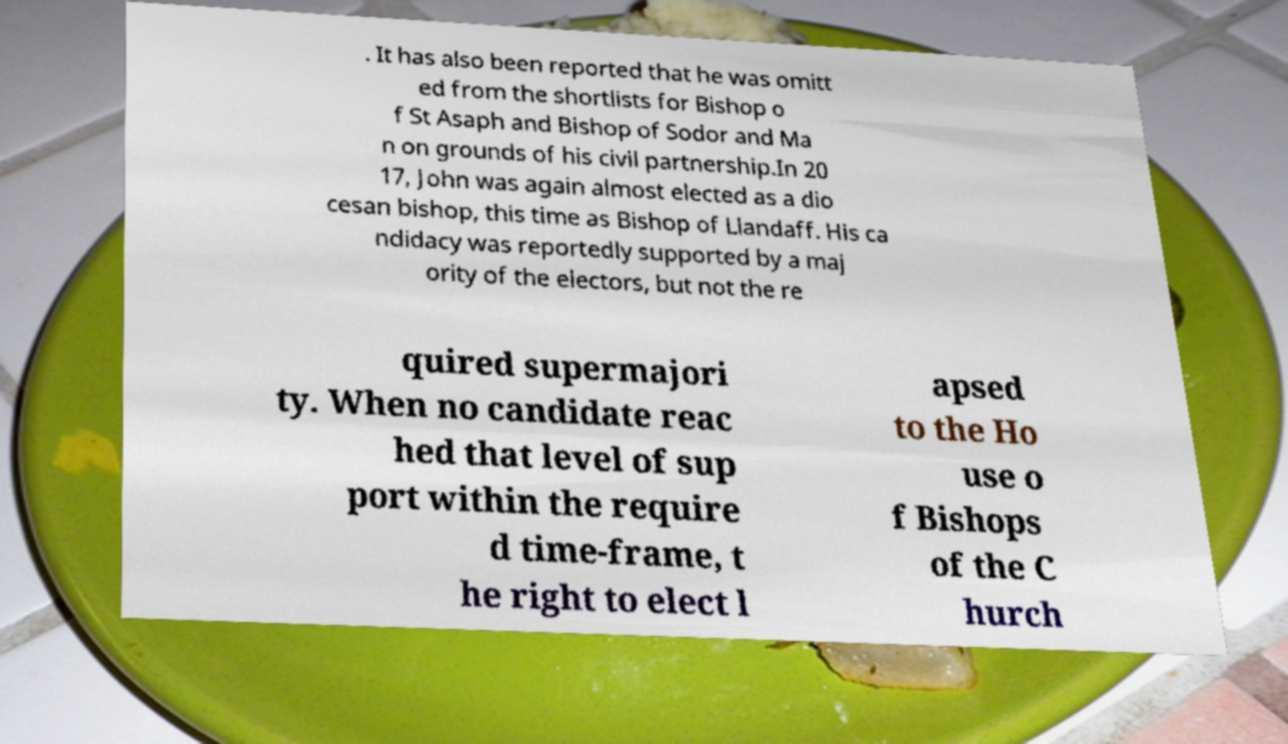Can you accurately transcribe the text from the provided image for me? . It has also been reported that he was omitt ed from the shortlists for Bishop o f St Asaph and Bishop of Sodor and Ma n on grounds of his civil partnership.In 20 17, John was again almost elected as a dio cesan bishop, this time as Bishop of Llandaff. His ca ndidacy was reportedly supported by a maj ority of the electors, but not the re quired supermajori ty. When no candidate reac hed that level of sup port within the require d time-frame, t he right to elect l apsed to the Ho use o f Bishops of the C hurch 